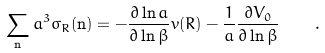<formula> <loc_0><loc_0><loc_500><loc_500>\sum _ { \mathbf n } a ^ { 3 } \sigma _ { R } ( { \mathbf n } ) = - \frac { \partial \ln a } { \partial \ln \beta } v ( R ) - \frac { 1 } { a } \frac { \partial V _ { 0 } } { \partial \ln \beta } \quad .</formula> 